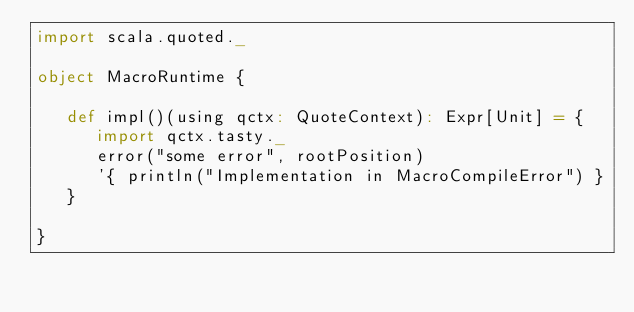Convert code to text. <code><loc_0><loc_0><loc_500><loc_500><_Scala_>import scala.quoted._

object MacroRuntime {

   def impl()(using qctx: QuoteContext): Expr[Unit] = {
      import qctx.tasty._
      error("some error", rootPosition)
      '{ println("Implementation in MacroCompileError") }
   }

}
</code> 